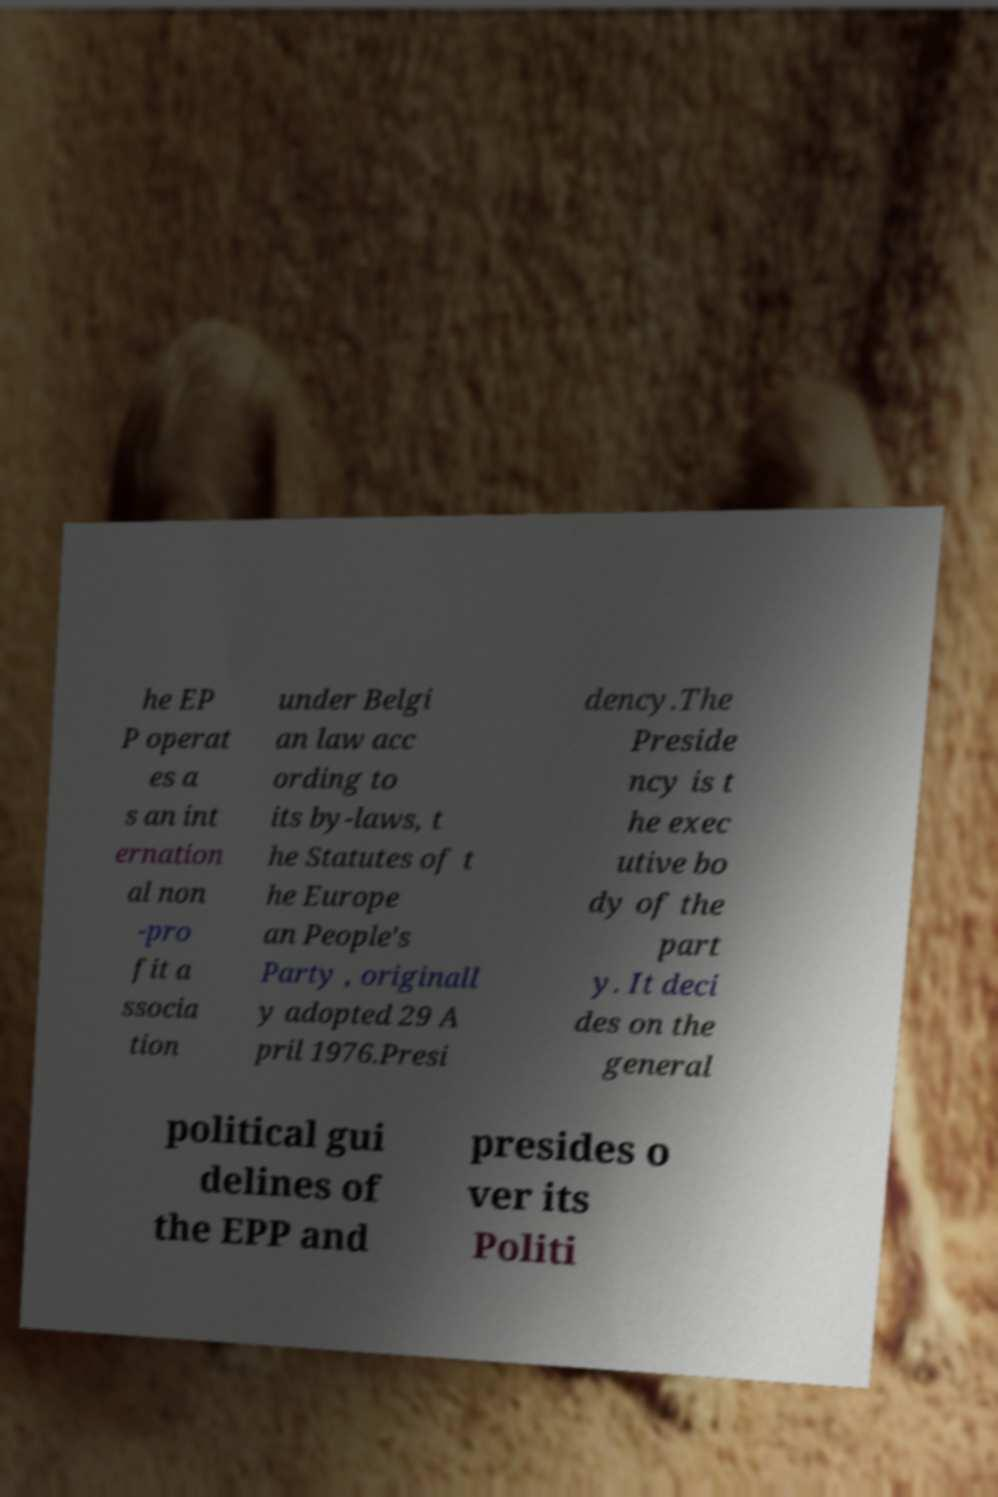Can you accurately transcribe the text from the provided image for me? he EP P operat es a s an int ernation al non -pro fit a ssocia tion under Belgi an law acc ording to its by-laws, t he Statutes of t he Europe an People's Party , originall y adopted 29 A pril 1976.Presi dency.The Preside ncy is t he exec utive bo dy of the part y. It deci des on the general political gui delines of the EPP and presides o ver its Politi 